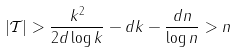<formula> <loc_0><loc_0><loc_500><loc_500>| \mathcal { T } | > \frac { k ^ { 2 } } { 2 d \log k } - d k - \frac { d n } { \log n } > n</formula> 